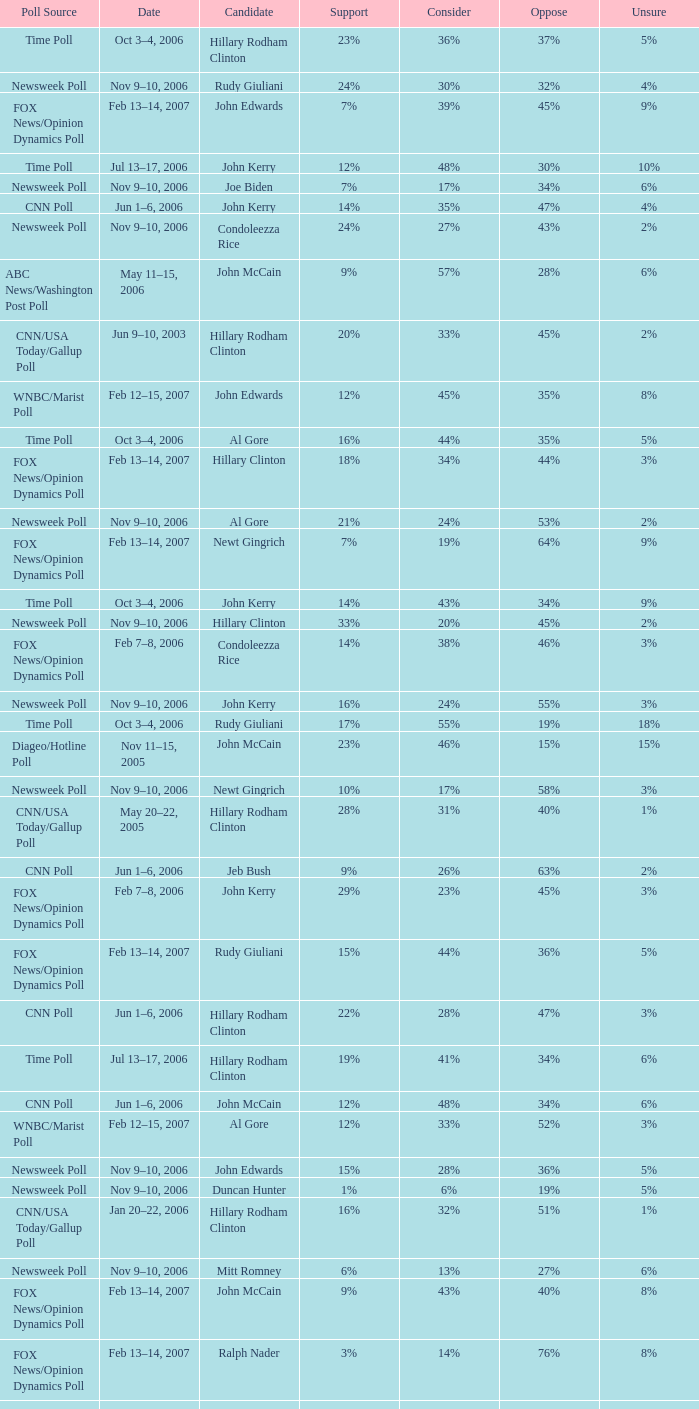What percentage of people said they would consider Rudy Giuliani as a candidate according to the Newsweek poll that showed 32% opposed him? 30%. Could you parse the entire table? {'header': ['Poll Source', 'Date', 'Candidate', 'Support', 'Consider', 'Oppose', 'Unsure'], 'rows': [['Time Poll', 'Oct 3–4, 2006', 'Hillary Rodham Clinton', '23%', '36%', '37%', '5%'], ['Newsweek Poll', 'Nov 9–10, 2006', 'Rudy Giuliani', '24%', '30%', '32%', '4%'], ['FOX News/Opinion Dynamics Poll', 'Feb 13–14, 2007', 'John Edwards', '7%', '39%', '45%', '9%'], ['Time Poll', 'Jul 13–17, 2006', 'John Kerry', '12%', '48%', '30%', '10%'], ['Newsweek Poll', 'Nov 9–10, 2006', 'Joe Biden', '7%', '17%', '34%', '6%'], ['CNN Poll', 'Jun 1–6, 2006', 'John Kerry', '14%', '35%', '47%', '4%'], ['Newsweek Poll', 'Nov 9–10, 2006', 'Condoleezza Rice', '24%', '27%', '43%', '2%'], ['ABC News/Washington Post Poll', 'May 11–15, 2006', 'John McCain', '9%', '57%', '28%', '6%'], ['CNN/USA Today/Gallup Poll', 'Jun 9–10, 2003', 'Hillary Rodham Clinton', '20%', '33%', '45%', '2%'], ['WNBC/Marist Poll', 'Feb 12–15, 2007', 'John Edwards', '12%', '45%', '35%', '8%'], ['Time Poll', 'Oct 3–4, 2006', 'Al Gore', '16%', '44%', '35%', '5%'], ['FOX News/Opinion Dynamics Poll', 'Feb 13–14, 2007', 'Hillary Clinton', '18%', '34%', '44%', '3%'], ['Newsweek Poll', 'Nov 9–10, 2006', 'Al Gore', '21%', '24%', '53%', '2%'], ['FOX News/Opinion Dynamics Poll', 'Feb 13–14, 2007', 'Newt Gingrich', '7%', '19%', '64%', '9%'], ['Time Poll', 'Oct 3–4, 2006', 'John Kerry', '14%', '43%', '34%', '9%'], ['Newsweek Poll', 'Nov 9–10, 2006', 'Hillary Clinton', '33%', '20%', '45%', '2%'], ['FOX News/Opinion Dynamics Poll', 'Feb 7–8, 2006', 'Condoleezza Rice', '14%', '38%', '46%', '3%'], ['Newsweek Poll', 'Nov 9–10, 2006', 'John Kerry', '16%', '24%', '55%', '3%'], ['Time Poll', 'Oct 3–4, 2006', 'Rudy Giuliani', '17%', '55%', '19%', '18%'], ['Diageo/Hotline Poll', 'Nov 11–15, 2005', 'John McCain', '23%', '46%', '15%', '15%'], ['Newsweek Poll', 'Nov 9–10, 2006', 'Newt Gingrich', '10%', '17%', '58%', '3%'], ['CNN/USA Today/Gallup Poll', 'May 20–22, 2005', 'Hillary Rodham Clinton', '28%', '31%', '40%', '1%'], ['CNN Poll', 'Jun 1–6, 2006', 'Jeb Bush', '9%', '26%', '63%', '2%'], ['FOX News/Opinion Dynamics Poll', 'Feb 7–8, 2006', 'John Kerry', '29%', '23%', '45%', '3%'], ['FOX News/Opinion Dynamics Poll', 'Feb 13–14, 2007', 'Rudy Giuliani', '15%', '44%', '36%', '5%'], ['CNN Poll', 'Jun 1–6, 2006', 'Hillary Rodham Clinton', '22%', '28%', '47%', '3%'], ['Time Poll', 'Jul 13–17, 2006', 'Hillary Rodham Clinton', '19%', '41%', '34%', '6%'], ['CNN Poll', 'Jun 1–6, 2006', 'John McCain', '12%', '48%', '34%', '6%'], ['WNBC/Marist Poll', 'Feb 12–15, 2007', 'Al Gore', '12%', '33%', '52%', '3%'], ['Newsweek Poll', 'Nov 9–10, 2006', 'John Edwards', '15%', '28%', '36%', '5%'], ['Newsweek Poll', 'Nov 9–10, 2006', 'Duncan Hunter', '1%', '6%', '19%', '5%'], ['CNN/USA Today/Gallup Poll', 'Jan 20–22, 2006', 'Hillary Rodham Clinton', '16%', '32%', '51%', '1%'], ['Newsweek Poll', 'Nov 9–10, 2006', 'Mitt Romney', '6%', '13%', '27%', '6%'], ['FOX News/Opinion Dynamics Poll', 'Feb 13–14, 2007', 'John McCain', '9%', '43%', '40%', '8%'], ['FOX News/Opinion Dynamics Poll', 'Feb 13–14, 2007', 'Ralph Nader', '3%', '14%', '76%', '8%'], ['FOX News/Opinion Dynamics Poll', 'Feb 13–14, 2007', 'Barack Obama', '12%', '45%', '34%', '10%'], ['Time Poll', 'Jul 13–17, 2006', 'Rudy Giuliani', '17%', '54%', '14%', '15%'], ['FOX News/Opinion Dynamics Poll', 'Feb 7–8, 2006', 'John McCain', '30%', '40%', '22%', '7%'], ['CNN Poll', 'Jun 1–6, 2006', 'Al Gore', '17%', '32%', '48%', '3%'], ['Time Poll', 'Jul 13–17, 2006', 'John McCain', '12%', '52%', '13%', '22%'], ['ABC News/Washington Post Poll', 'May 11–15, 2006', 'Hillary Clinton', '19%', '38%', '42%', '1%'], ['WNBC/Marist Poll', 'Feb 12–15, 2007', 'John McCain', '14%', '44%', '37%', '5%'], ['FOX News/Opinion Dynamics Poll', 'Feb 7–8, 2006', 'Hillary Clinton', '35%', '19%', '44%', '2%'], ['FOX News/Opinion Dynamics Poll', 'Feb 7–8, 2006', 'Rudy Giuliani', '33%', '38%', '24%', '6%'], ['WNBC/Marist Poll', 'Feb 12–15, 2007', 'Rudy Giuliani', '16%', '51%', '30%', '3%'], ['WNBC/Marist Poll', 'Feb 12–15, 2007', 'Mitt Romney', '7%', '25%', '44%', '24%'], ['CNN Poll', 'Jun 1–6, 2006', 'Rudolph Giuliani', '19%', '45%', '30%', '6%'], ['WNBC/Marist Poll', 'Feb 12–15, 2007', 'Hillary Clinton', '25%', '30%', '43%', '2%'], ['Time Poll', 'Oct 3–4, 2006', 'John McCain', '12%', '56%', '19%', '13%'], ['Time Poll', 'Jul 13–17, 2006', 'Al Gore', '16%', '45%', '32%', '7%'], ['Newsweek Poll', 'Nov 9–10, 2006', 'Barack Obama', '20%', '19%', '24%', '3%'], ['WNBC/Marist Poll', 'Feb 12–15, 2007', 'Barack Obama', '17%', '42%', '32%', '9%'], ['Newsweek Poll', 'Nov 9–10, 2006', 'Sam Brownback', '3%', '7%', '23%', '6%'], ['Newsweek Poll', 'Nov 9–10, 2006', 'John McCain', '20%', '34%', '32%', '4%'], ['WNBC/Marist Poll', 'Feb 12–15, 2007', 'Newt Gingrich', '6%', '25%', '64%', '5%']]} 